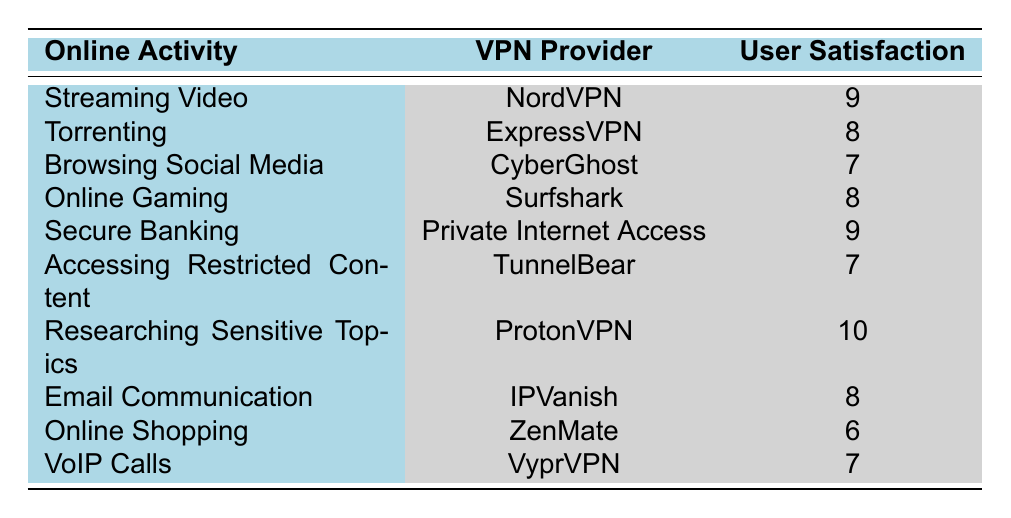What is the user satisfaction rating for Surfshark? According to the table, Surfshark has a user satisfaction rating of 8.
Answer: 8 Which online activity has the highest user satisfaction rating? The highest user satisfaction rating is 10, which corresponds to the online activity "Researching Sensitive Topics" using ProtonVPN.
Answer: Researching Sensitive Topics Is NordVPN rated higher than CyberGhost? NordVPN has a satisfaction rating of 9, while CyberGhost has a rating of 7. Since 9 is higher than 7, the statement is true.
Answer: Yes What is the average user satisfaction rating for all listed VPN providers? To find the average, sum the ratings: 9 + 8 + 7 + 8 + 9 + 7 + 10 + 8 + 6 + 7 = 78. There are 10 ratings, so the average is 78 / 10 = 7.8.
Answer: 7.8 Are there more VPN providers with a rating of 8 than those with a rating of 6? There are three providers with a rating of 8 (NordVPN, ExpressVPN, Surfshark, and IPVanish) and one provider with a rating of 6 (ZenMate). Therefore, the number of providers with a rating of 8 is greater than those with a rating of 6.
Answer: Yes What is the difference between the highest and lowest user satisfaction ratings? The highest rating is 10 (Researching Sensitive Topics - ProtonVPN) and the lowest is 6 (Online Shopping - ZenMate). Therefore, the difference is 10 - 6 = 4.
Answer: 4 Which VPN provider is associated with online shopping, and what is its user satisfaction rating? ZenMate is the VPN provider associated with online shopping, and it has a user satisfaction rating of 6.
Answer: ZenMate, 6 How many online activities have a user satisfaction rating of 7? By reviewing the table, there are four activities with a satisfaction rating of 7: "Browsing Social Media," "Accessing Restricted Content," "VoIP Calls," and "Researching Sensitive Topics."
Answer: 4 Is there any VPN provider that offers protection for secure banking with a satisfaction rating of 9? Yes, Private Internet Access provides protection for secure banking with a satisfaction rating of 9.
Answer: Yes 